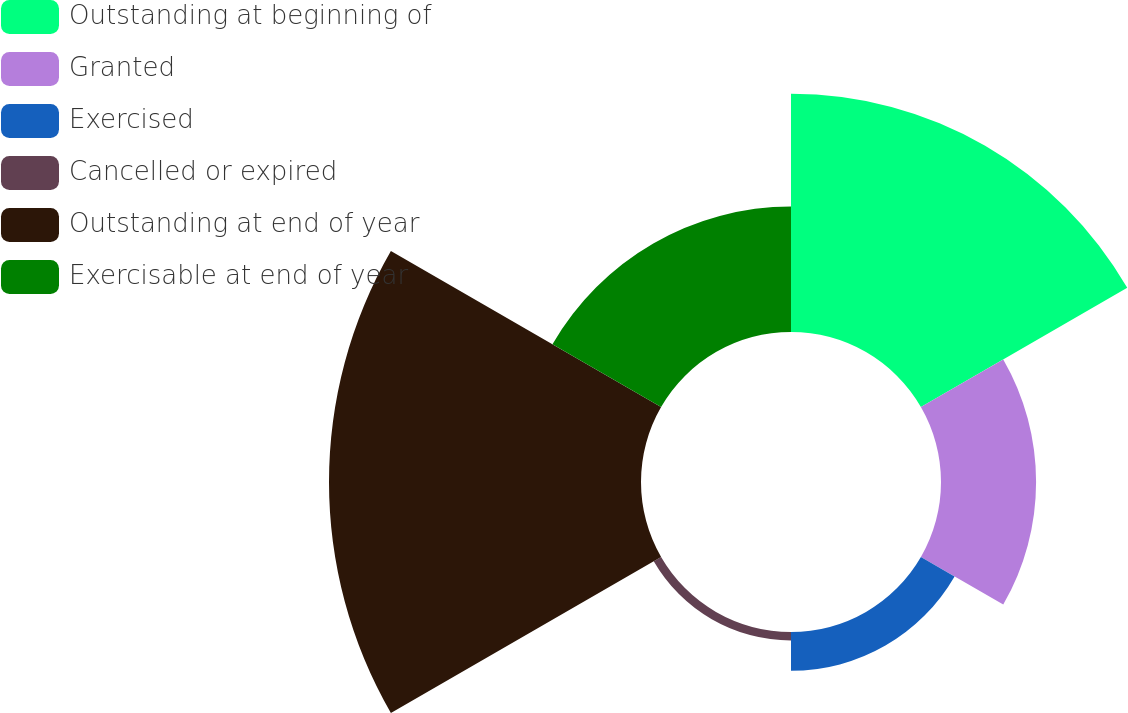<chart> <loc_0><loc_0><loc_500><loc_500><pie_chart><fcel>Outstanding at beginning of<fcel>Granted<fcel>Exercised<fcel>Cancelled or expired<fcel>Outstanding at end of year<fcel>Exercisable at end of year<nl><fcel>29.12%<fcel>11.62%<fcel>4.75%<fcel>1.04%<fcel>38.13%<fcel>15.33%<nl></chart> 